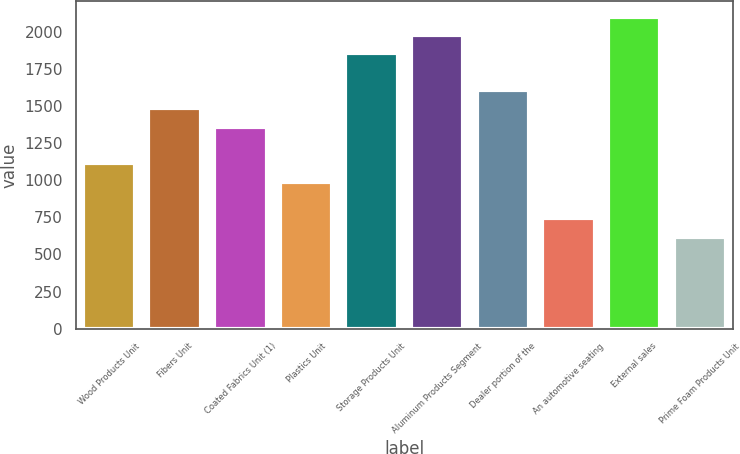Convert chart. <chart><loc_0><loc_0><loc_500><loc_500><bar_chart><fcel>Wood Products Unit<fcel>Fibers Unit<fcel>Coated Fabrics Unit (1)<fcel>Plastics Unit<fcel>Storage Products Unit<fcel>Aluminum Products Segment<fcel>Dealer portion of the<fcel>An automotive seating<fcel>External sales<fcel>Prime Foam Products Unit<nl><fcel>1114.66<fcel>1486.18<fcel>1362.34<fcel>990.82<fcel>1857.7<fcel>1981.54<fcel>1610.02<fcel>743.14<fcel>2105.38<fcel>619.3<nl></chart> 